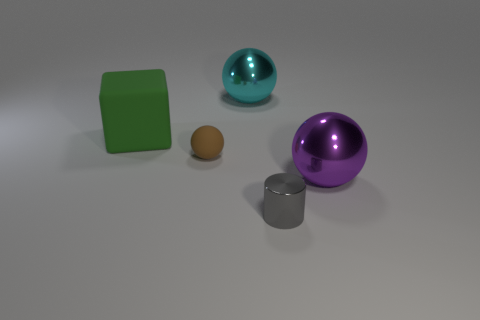Which object stands out the most in this composition, and why might that be? The cyan ball stands out the most due to its larger size and vibrant color that contrasts with the otherwise muted surroundings. If you had to guess what material each object is made of solely based on their appearance, what would you say? The large cyan and the purple objects might be plastic or rubber balls due to their shiny texture, the brown object resembles a smaller rubber ball, the green object could be a plastic or wooden cube given its matte finish, and the cylinder looks metallic, potentially stainless steel, due to its reflective surface. 